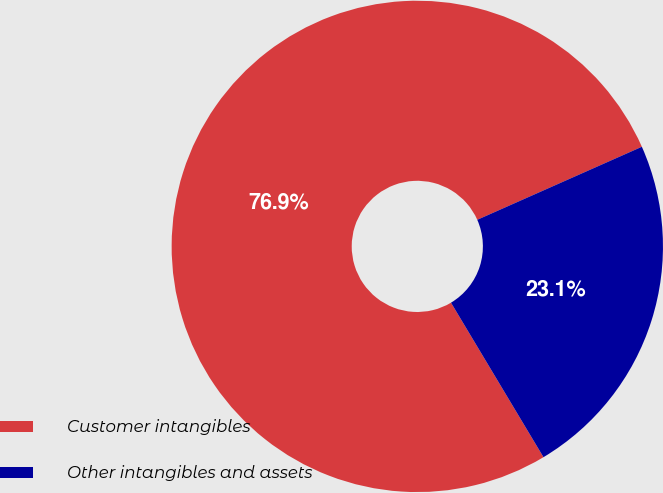Convert chart to OTSL. <chart><loc_0><loc_0><loc_500><loc_500><pie_chart><fcel>Customer intangibles<fcel>Other intangibles and assets<nl><fcel>76.94%<fcel>23.06%<nl></chart> 